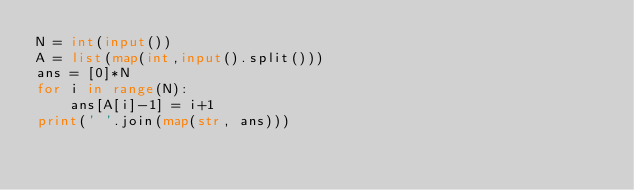<code> <loc_0><loc_0><loc_500><loc_500><_Python_>N = int(input())
A = list(map(int,input().split()))
ans = [0]*N
for i in range(N):
    ans[A[i]-1] = i+1
print(' '.join(map(str, ans)))
</code> 